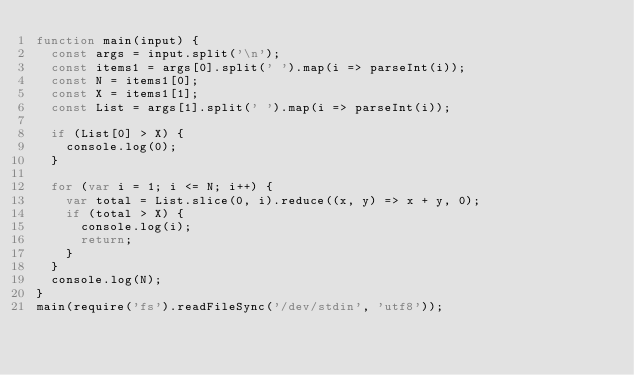Convert code to text. <code><loc_0><loc_0><loc_500><loc_500><_JavaScript_>function main(input) {
  const args = input.split('\n');
  const items1 = args[0].split(' ').map(i => parseInt(i));
  const N = items1[0];
  const X = items1[1];
  const List = args[1].split(' ').map(i => parseInt(i));

  if (List[0] > X) {
    console.log(0);
  }

  for (var i = 1; i <= N; i++) {
    var total = List.slice(0, i).reduce((x, y) => x + y, 0);
    if (total > X) {
      console.log(i);
      return;
    }
  }
  console.log(N);
}
main(require('fs').readFileSync('/dev/stdin', 'utf8'));
</code> 